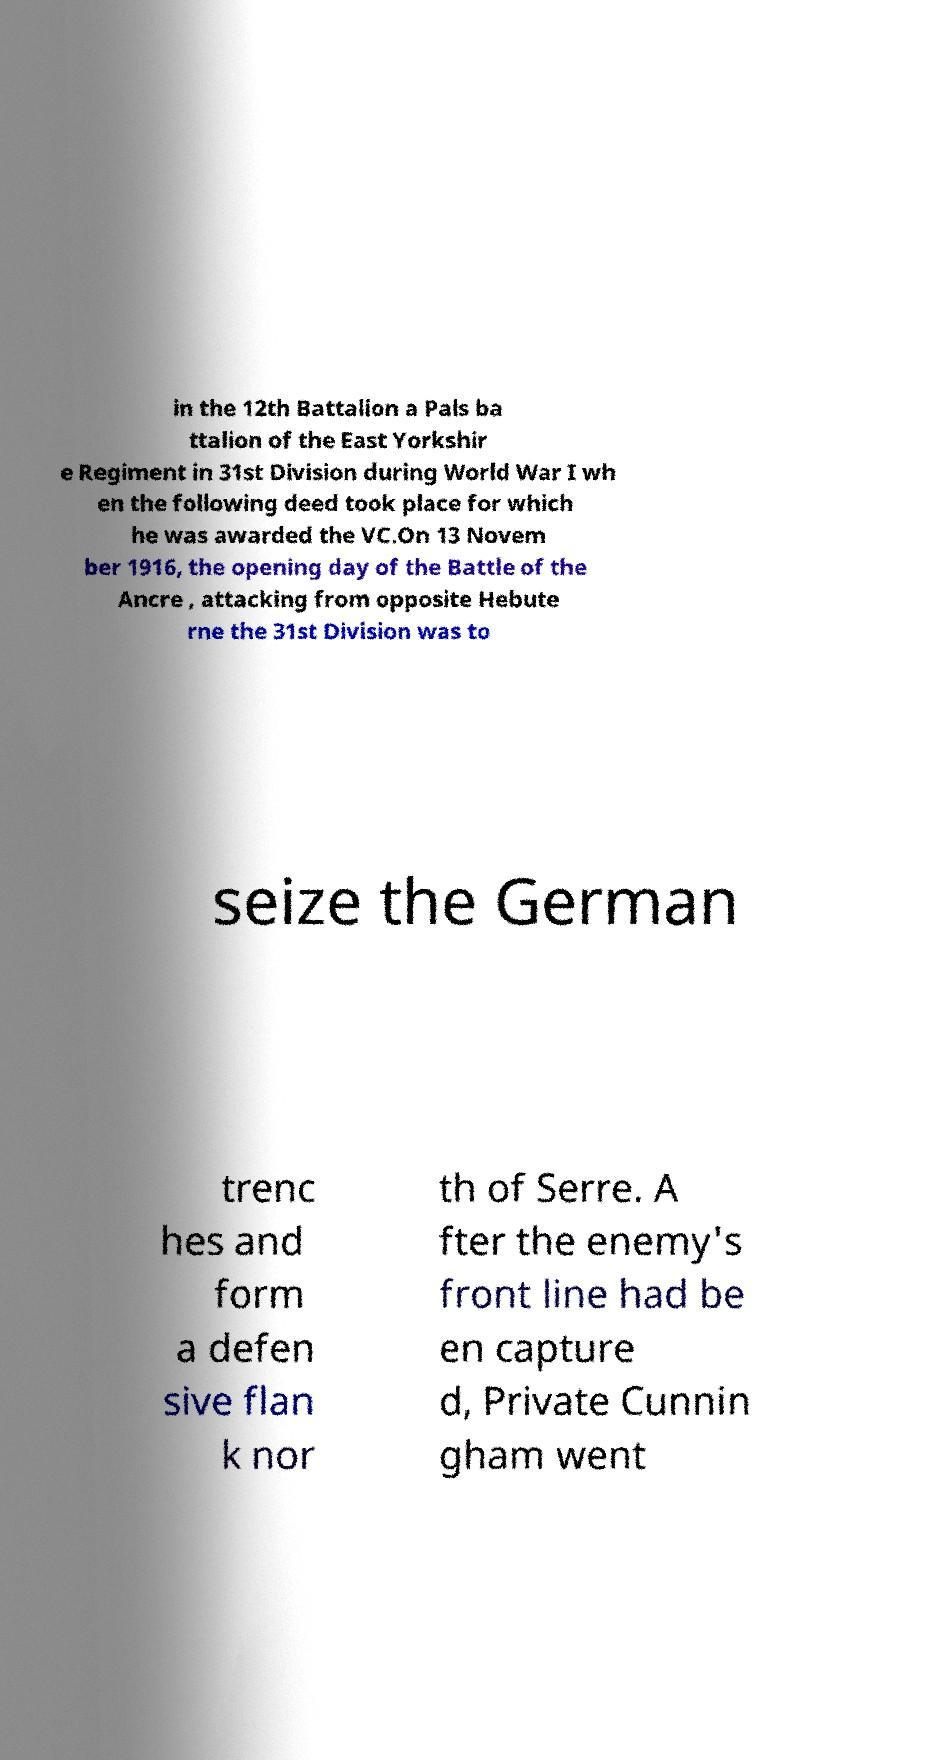Can you accurately transcribe the text from the provided image for me? in the 12th Battalion a Pals ba ttalion of the East Yorkshir e Regiment in 31st Division during World War I wh en the following deed took place for which he was awarded the VC.On 13 Novem ber 1916, the opening day of the Battle of the Ancre , attacking from opposite Hebute rne the 31st Division was to seize the German trenc hes and form a defen sive flan k nor th of Serre. A fter the enemy's front line had be en capture d, Private Cunnin gham went 